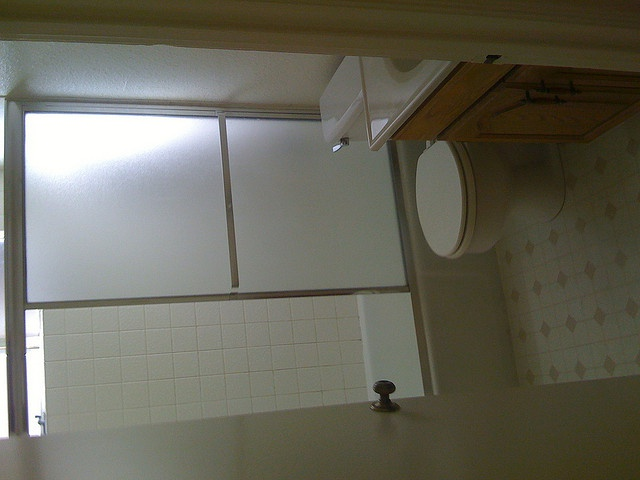Describe the objects in this image and their specific colors. I can see toilet in black and gray tones and sink in black, gray, and darkgray tones in this image. 